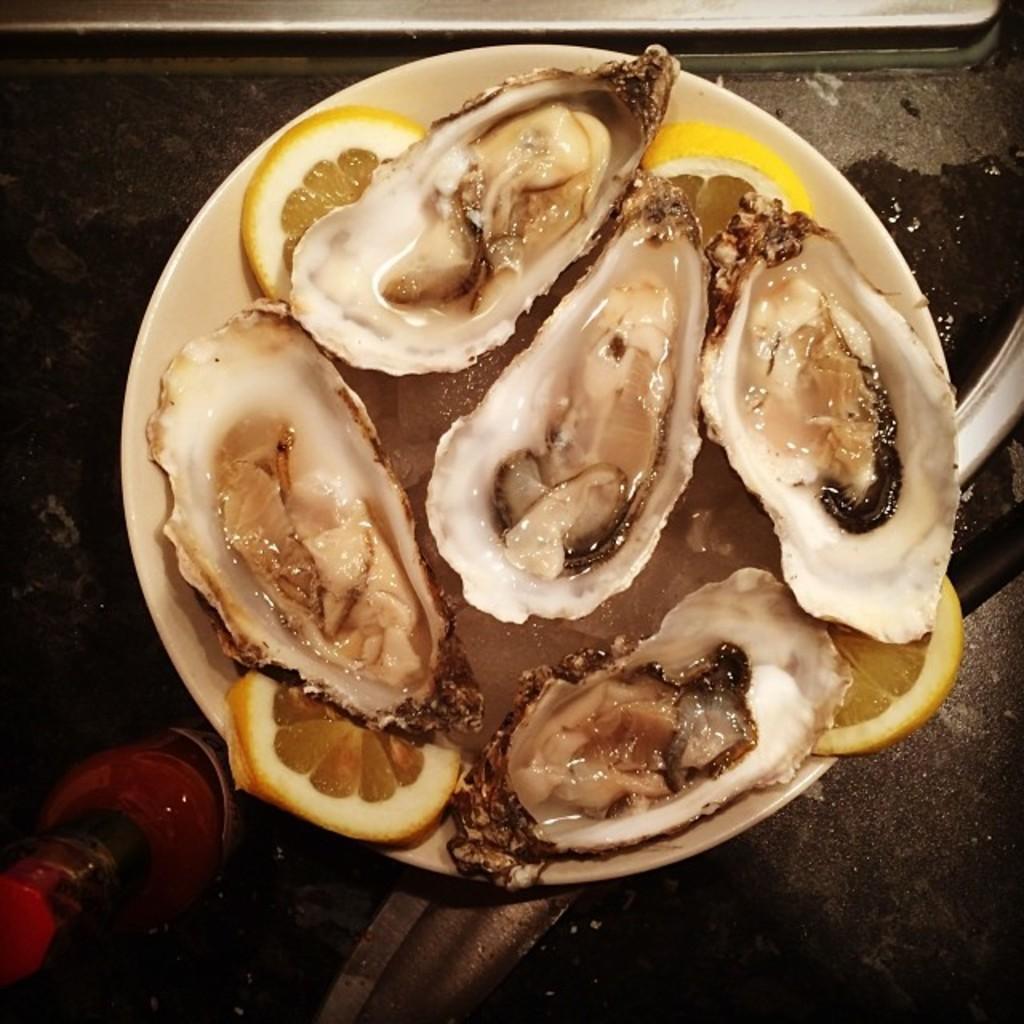Describe this image in one or two sentences. In this image, in the middle, we can see a plate with some food item. On the right side of the image, we can also see a knife. On the left side, we can see a bottle. In the background, we can see metal instrument, at the bottom, we can see water on the floor. 